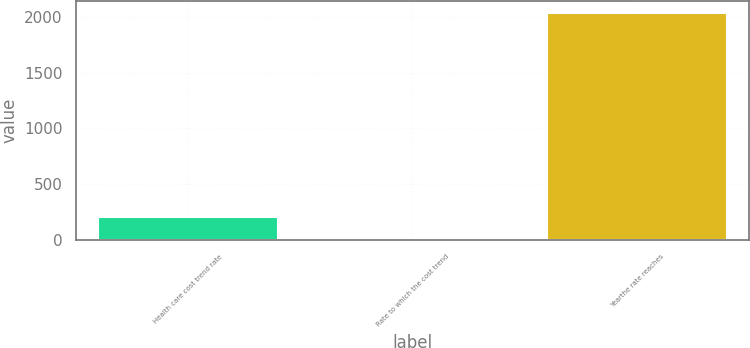<chart> <loc_0><loc_0><loc_500><loc_500><bar_chart><fcel>Health care cost trend rate<fcel>Rate to which the cost trend<fcel>Yearthe rate reaches<nl><fcel>207.69<fcel>4.43<fcel>2037<nl></chart> 